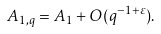Convert formula to latex. <formula><loc_0><loc_0><loc_500><loc_500>A _ { 1 , q } = A _ { 1 } + O ( q ^ { - 1 + \varepsilon } ) .</formula> 